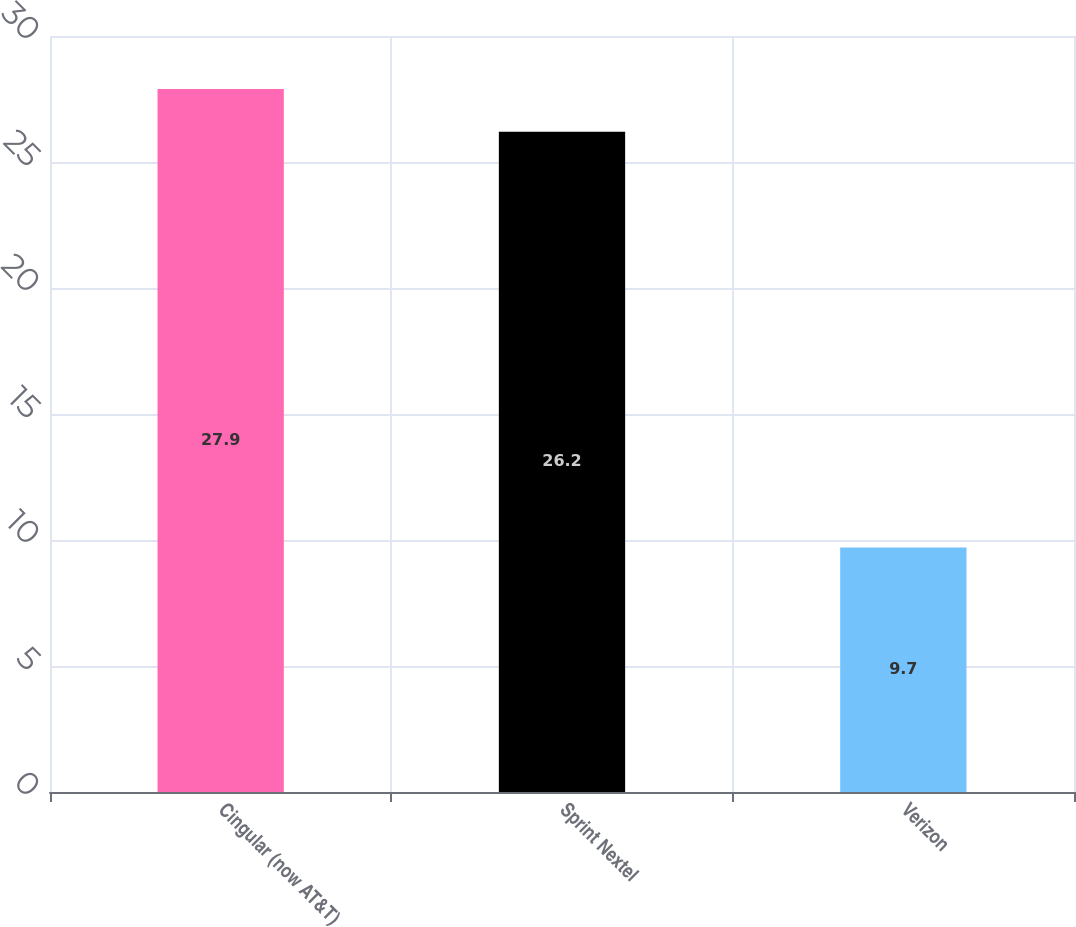<chart> <loc_0><loc_0><loc_500><loc_500><bar_chart><fcel>Cingular (now AT&T)<fcel>Sprint Nextel<fcel>Verizon<nl><fcel>27.9<fcel>26.2<fcel>9.7<nl></chart> 